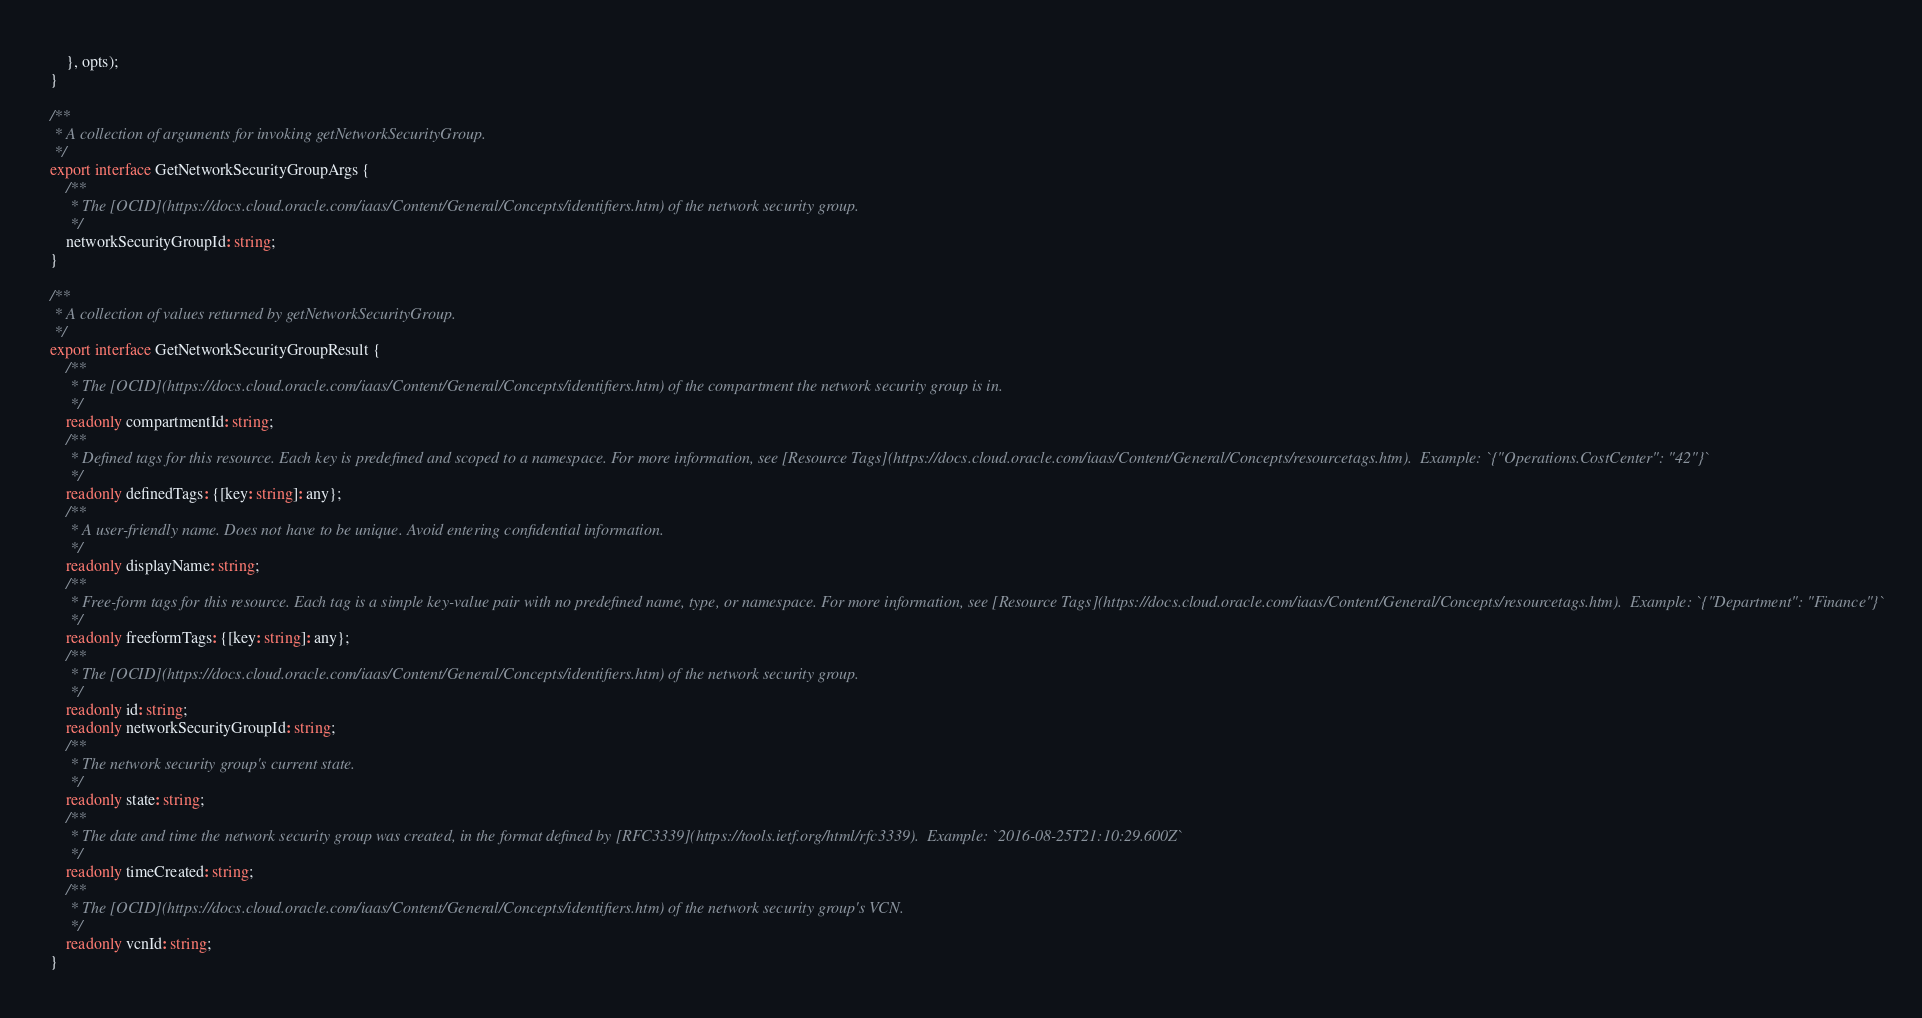Convert code to text. <code><loc_0><loc_0><loc_500><loc_500><_TypeScript_>    }, opts);
}

/**
 * A collection of arguments for invoking getNetworkSecurityGroup.
 */
export interface GetNetworkSecurityGroupArgs {
    /**
     * The [OCID](https://docs.cloud.oracle.com/iaas/Content/General/Concepts/identifiers.htm) of the network security group.
     */
    networkSecurityGroupId: string;
}

/**
 * A collection of values returned by getNetworkSecurityGroup.
 */
export interface GetNetworkSecurityGroupResult {
    /**
     * The [OCID](https://docs.cloud.oracle.com/iaas/Content/General/Concepts/identifiers.htm) of the compartment the network security group is in.
     */
    readonly compartmentId: string;
    /**
     * Defined tags for this resource. Each key is predefined and scoped to a namespace. For more information, see [Resource Tags](https://docs.cloud.oracle.com/iaas/Content/General/Concepts/resourcetags.htm).  Example: `{"Operations.CostCenter": "42"}`
     */
    readonly definedTags: {[key: string]: any};
    /**
     * A user-friendly name. Does not have to be unique. Avoid entering confidential information.
     */
    readonly displayName: string;
    /**
     * Free-form tags for this resource. Each tag is a simple key-value pair with no predefined name, type, or namespace. For more information, see [Resource Tags](https://docs.cloud.oracle.com/iaas/Content/General/Concepts/resourcetags.htm).  Example: `{"Department": "Finance"}`
     */
    readonly freeformTags: {[key: string]: any};
    /**
     * The [OCID](https://docs.cloud.oracle.com/iaas/Content/General/Concepts/identifiers.htm) of the network security group.
     */
    readonly id: string;
    readonly networkSecurityGroupId: string;
    /**
     * The network security group's current state.
     */
    readonly state: string;
    /**
     * The date and time the network security group was created, in the format defined by [RFC3339](https://tools.ietf.org/html/rfc3339).  Example: `2016-08-25T21:10:29.600Z`
     */
    readonly timeCreated: string;
    /**
     * The [OCID](https://docs.cloud.oracle.com/iaas/Content/General/Concepts/identifiers.htm) of the network security group's VCN.
     */
    readonly vcnId: string;
}
</code> 